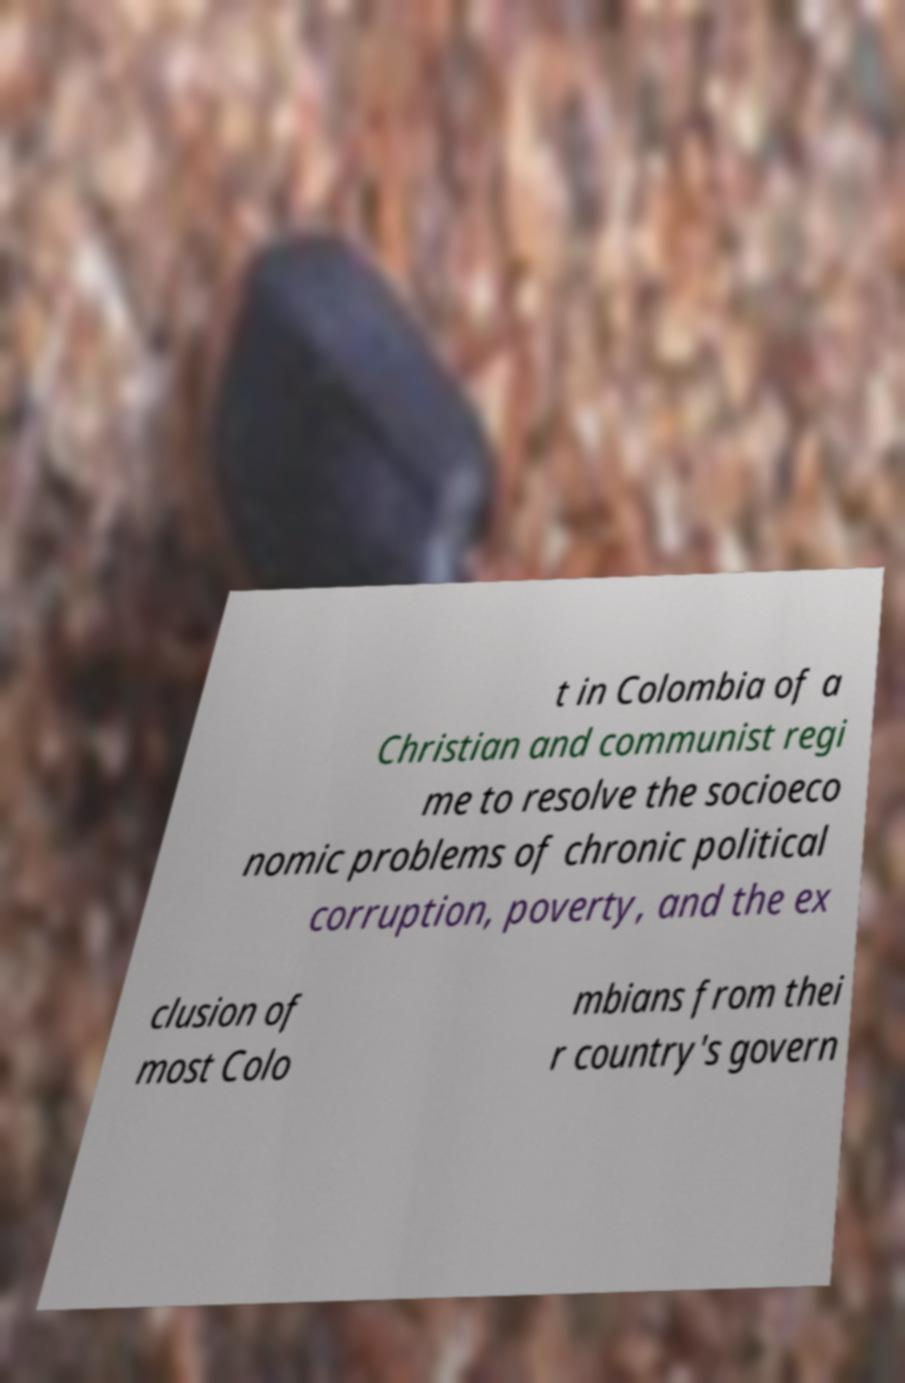Please identify and transcribe the text found in this image. t in Colombia of a Christian and communist regi me to resolve the socioeco nomic problems of chronic political corruption, poverty, and the ex clusion of most Colo mbians from thei r country's govern 